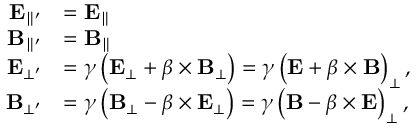Convert formula to latex. <formula><loc_0><loc_0><loc_500><loc_500>{ \begin{array} { r l } { E _ { \| ^ { \prime } } } & { = E _ { \| } } \\ { B _ { \| ^ { \prime } } } & { = B _ { \| } } \\ { E _ { \bot ^ { \prime } } } & { = \gamma \left ( E _ { \bot } + { \beta } \times B _ { \bot } \right ) = \gamma \left ( E + { \beta } \times B \right ) _ { \bot } , } \\ { B _ { \bot ^ { \prime } } } & { = \gamma \left ( B _ { \bot } - { \beta } \times E _ { \bot } \right ) = \gamma \left ( B - { \beta } \times E \right ) _ { \bot } , } \end{array} }</formula> 